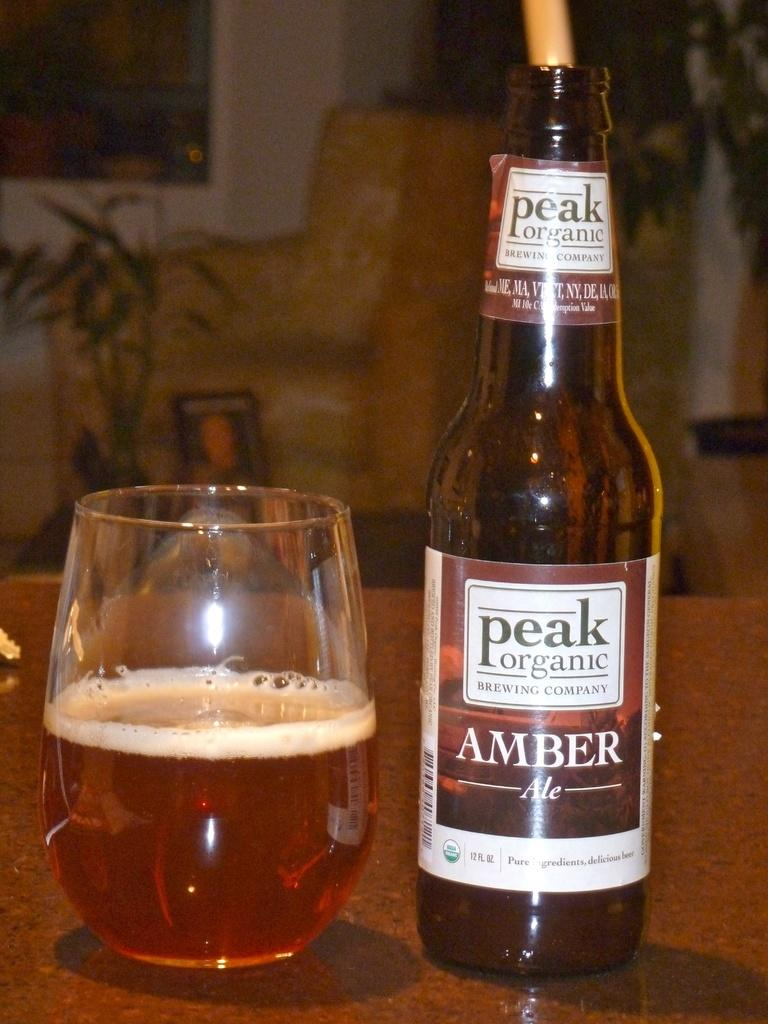<image>
Render a clear and concise summary of the photo. Peak Organic Amber Ale next to a half empty cup of beer. 